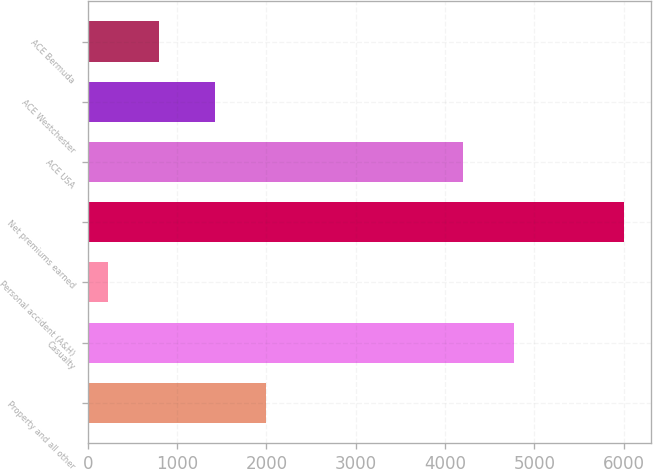<chart> <loc_0><loc_0><loc_500><loc_500><bar_chart><fcel>Property and all other<fcel>Casualty<fcel>Personal accident (A&H)<fcel>Net premiums earned<fcel>ACE USA<fcel>ACE Westchester<fcel>ACE Bermuda<nl><fcel>1998.4<fcel>4774.4<fcel>223<fcel>6007<fcel>4196<fcel>1420<fcel>801.4<nl></chart> 